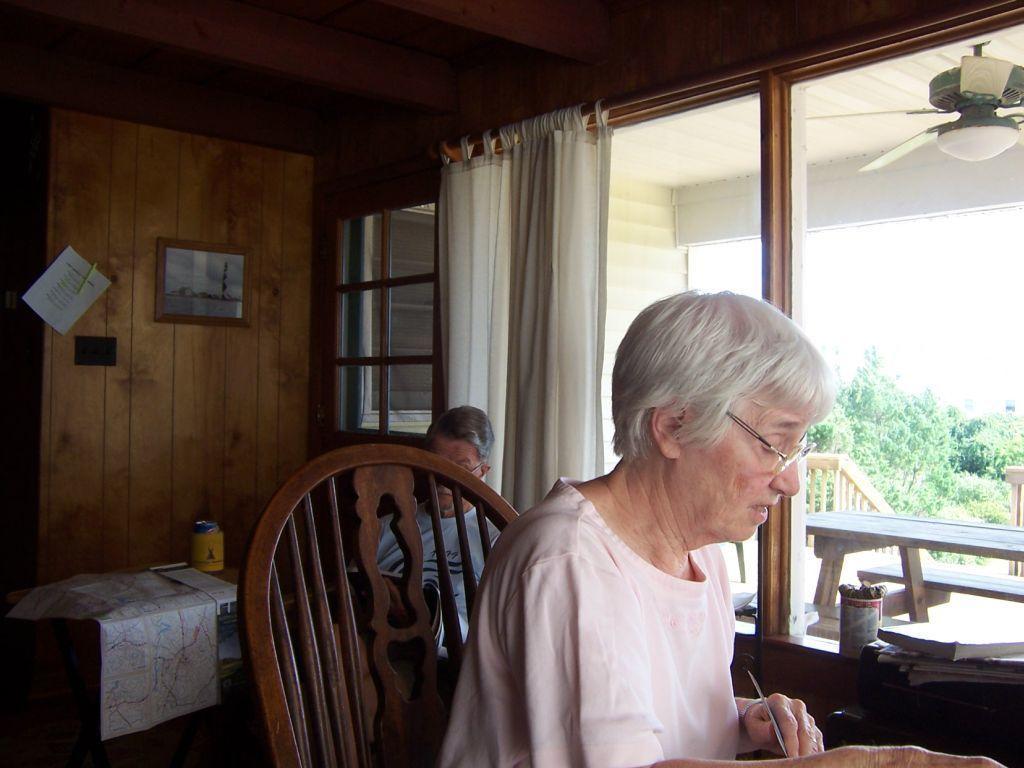Describe this image in one or two sentences. A woman with pink dress is sitting on a chair. Behind her there is a table. On the table there is a map and some box. To the right side there is a man sitting. There is a window and a curtain to it. In the right side bottom corner there is a bench and some trees. To the wall there is a frame and a paper. 